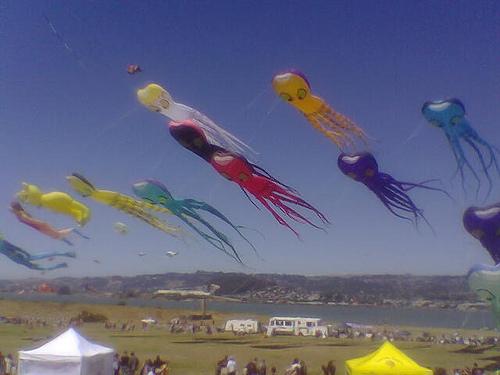Have you ever seen objects like that flying in the sky?
Answer briefly. Yes. Can you see a tent?
Give a very brief answer. Yes. How many thin striped kites are flying in the air?
Give a very brief answer. 10. How many kites are there?
Be succinct. 17. Are they flying there in the United States?
Quick response, please. Yes. 